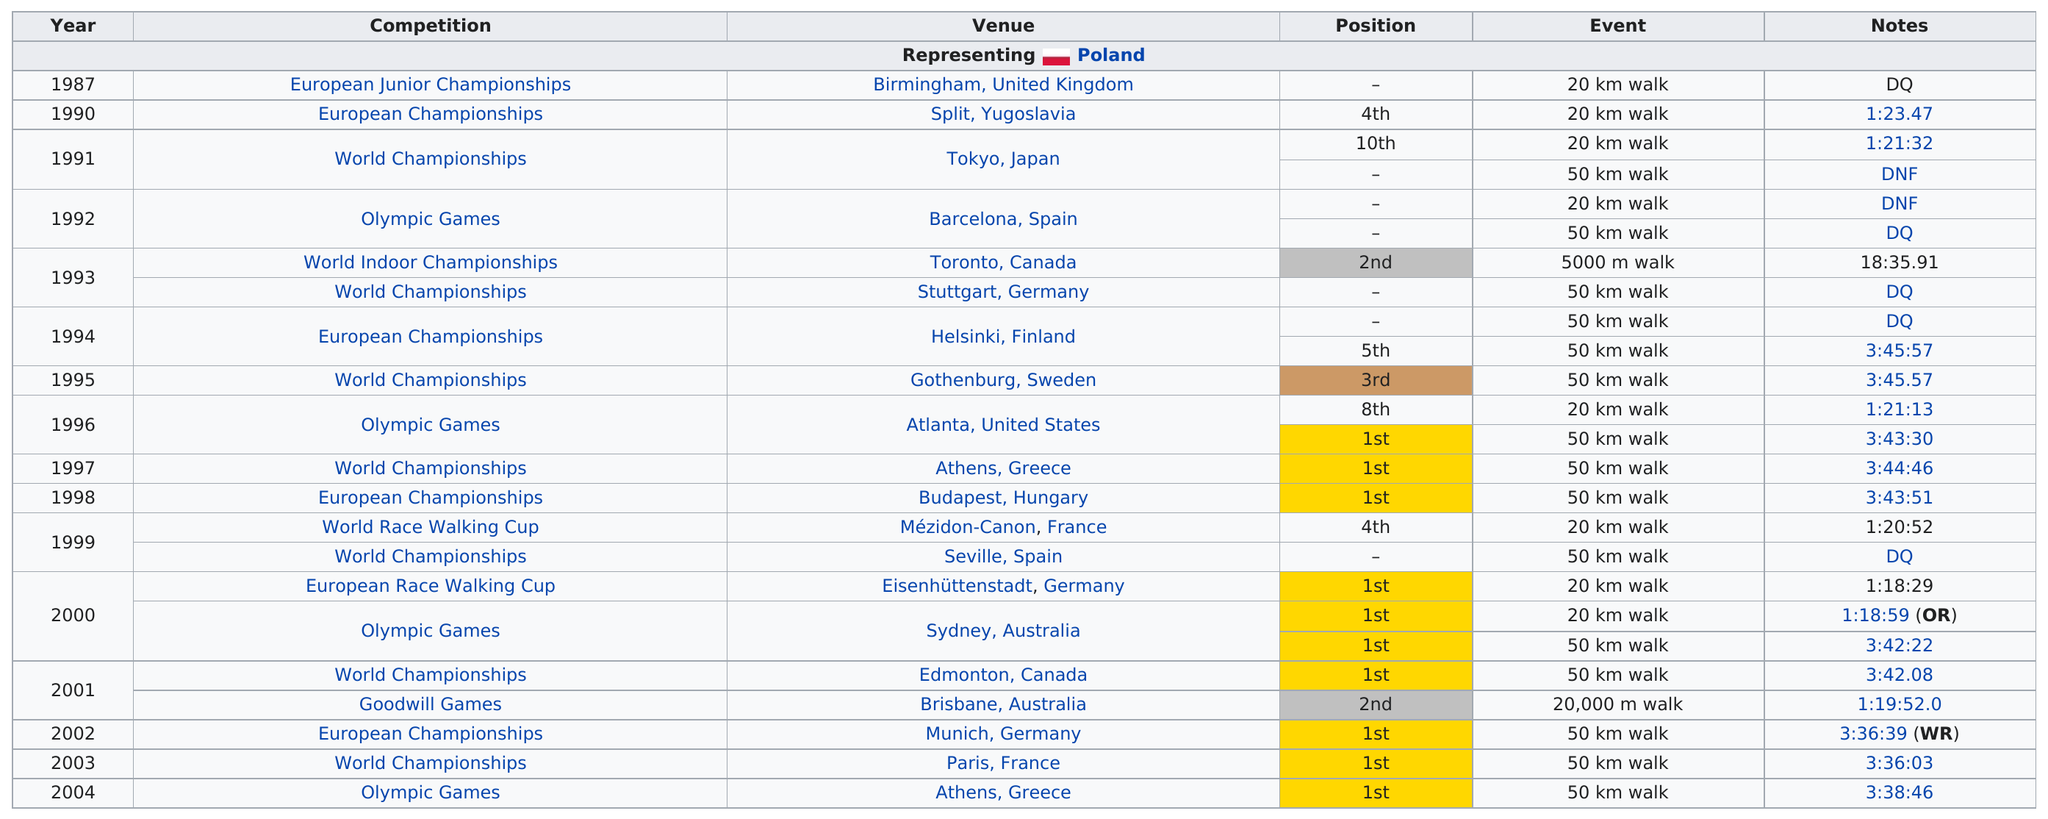List a handful of essential elements in this visual. There were 17 events that were at least 50 kilometers. The competition that featured a longer walk was the World Indoor Championships. Korzeniowski was disqualified from a competition a total of 5 times. First place was listed as the position 10 times. Korzeniowski finished above fourth place 13 times. 